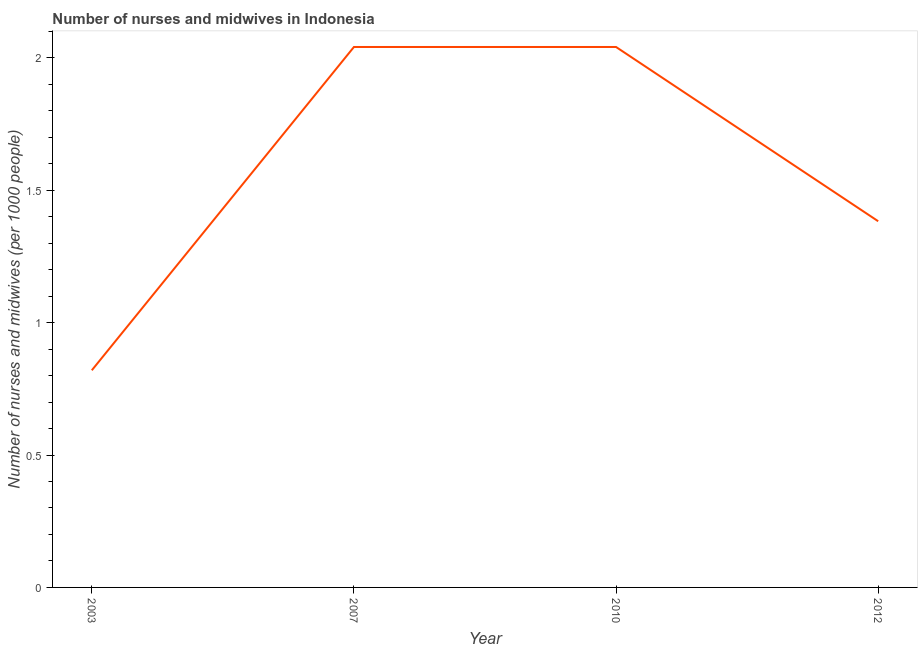What is the number of nurses and midwives in 2010?
Your answer should be compact. 2.04. Across all years, what is the maximum number of nurses and midwives?
Provide a succinct answer. 2.04. Across all years, what is the minimum number of nurses and midwives?
Provide a short and direct response. 0.82. What is the sum of the number of nurses and midwives?
Offer a very short reply. 6.28. What is the average number of nurses and midwives per year?
Your answer should be very brief. 1.57. What is the median number of nurses and midwives?
Provide a short and direct response. 1.71. In how many years, is the number of nurses and midwives greater than 0.1 ?
Make the answer very short. 4. Do a majority of the years between 2003 and 2007 (inclusive) have number of nurses and midwives greater than 1.3 ?
Your answer should be compact. No. What is the ratio of the number of nurses and midwives in 2003 to that in 2007?
Give a very brief answer. 0.4. Is the number of nurses and midwives in 2003 less than that in 2010?
Offer a very short reply. Yes. Is the sum of the number of nurses and midwives in 2003 and 2007 greater than the maximum number of nurses and midwives across all years?
Keep it short and to the point. Yes. What is the difference between the highest and the lowest number of nurses and midwives?
Your response must be concise. 1.22. Does the number of nurses and midwives monotonically increase over the years?
Your answer should be very brief. No. How many lines are there?
Keep it short and to the point. 1. How many years are there in the graph?
Offer a terse response. 4. What is the difference between two consecutive major ticks on the Y-axis?
Provide a succinct answer. 0.5. Does the graph contain any zero values?
Ensure brevity in your answer.  No. Does the graph contain grids?
Provide a short and direct response. No. What is the title of the graph?
Your answer should be very brief. Number of nurses and midwives in Indonesia. What is the label or title of the X-axis?
Your response must be concise. Year. What is the label or title of the Y-axis?
Your answer should be compact. Number of nurses and midwives (per 1000 people). What is the Number of nurses and midwives (per 1000 people) in 2003?
Make the answer very short. 0.82. What is the Number of nurses and midwives (per 1000 people) in 2007?
Give a very brief answer. 2.04. What is the Number of nurses and midwives (per 1000 people) in 2010?
Keep it short and to the point. 2.04. What is the Number of nurses and midwives (per 1000 people) of 2012?
Keep it short and to the point. 1.38. What is the difference between the Number of nurses and midwives (per 1000 people) in 2003 and 2007?
Offer a very short reply. -1.22. What is the difference between the Number of nurses and midwives (per 1000 people) in 2003 and 2010?
Your response must be concise. -1.22. What is the difference between the Number of nurses and midwives (per 1000 people) in 2003 and 2012?
Offer a terse response. -0.56. What is the difference between the Number of nurses and midwives (per 1000 people) in 2007 and 2012?
Offer a very short reply. 0.66. What is the difference between the Number of nurses and midwives (per 1000 people) in 2010 and 2012?
Offer a very short reply. 0.66. What is the ratio of the Number of nurses and midwives (per 1000 people) in 2003 to that in 2007?
Ensure brevity in your answer.  0.4. What is the ratio of the Number of nurses and midwives (per 1000 people) in 2003 to that in 2010?
Offer a very short reply. 0.4. What is the ratio of the Number of nurses and midwives (per 1000 people) in 2003 to that in 2012?
Provide a succinct answer. 0.59. What is the ratio of the Number of nurses and midwives (per 1000 people) in 2007 to that in 2010?
Provide a succinct answer. 1. What is the ratio of the Number of nurses and midwives (per 1000 people) in 2007 to that in 2012?
Offer a terse response. 1.48. What is the ratio of the Number of nurses and midwives (per 1000 people) in 2010 to that in 2012?
Offer a very short reply. 1.48. 